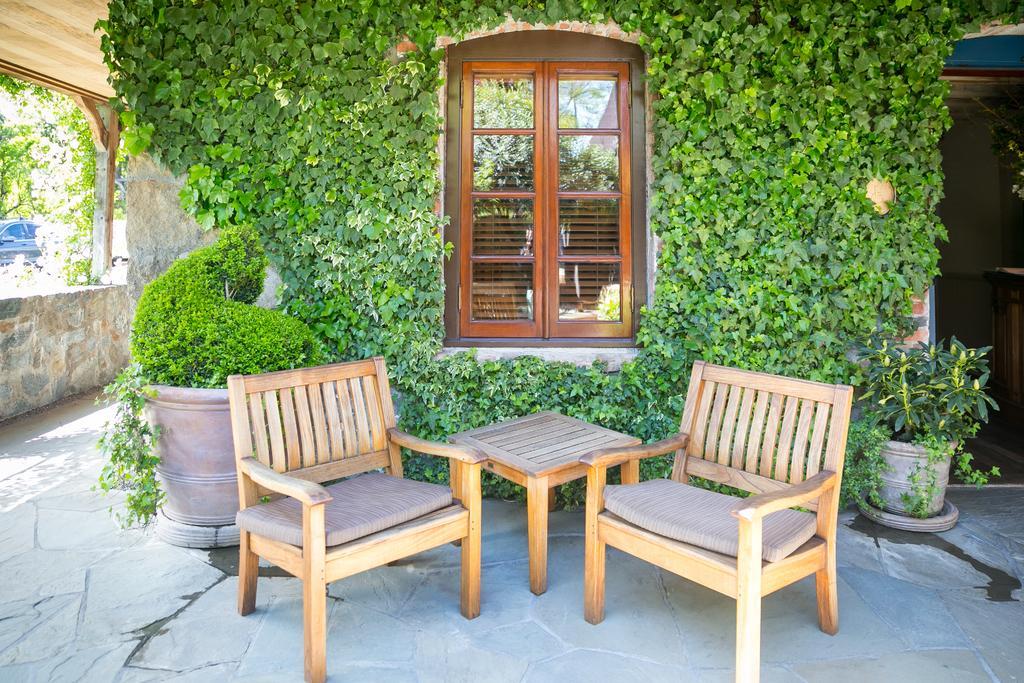In one or two sentences, can you explain what this image depicts? In the image there is a table and chairs on the floor,it seems to be balcony and in the middle there is a window and all over the sides there are plants. 